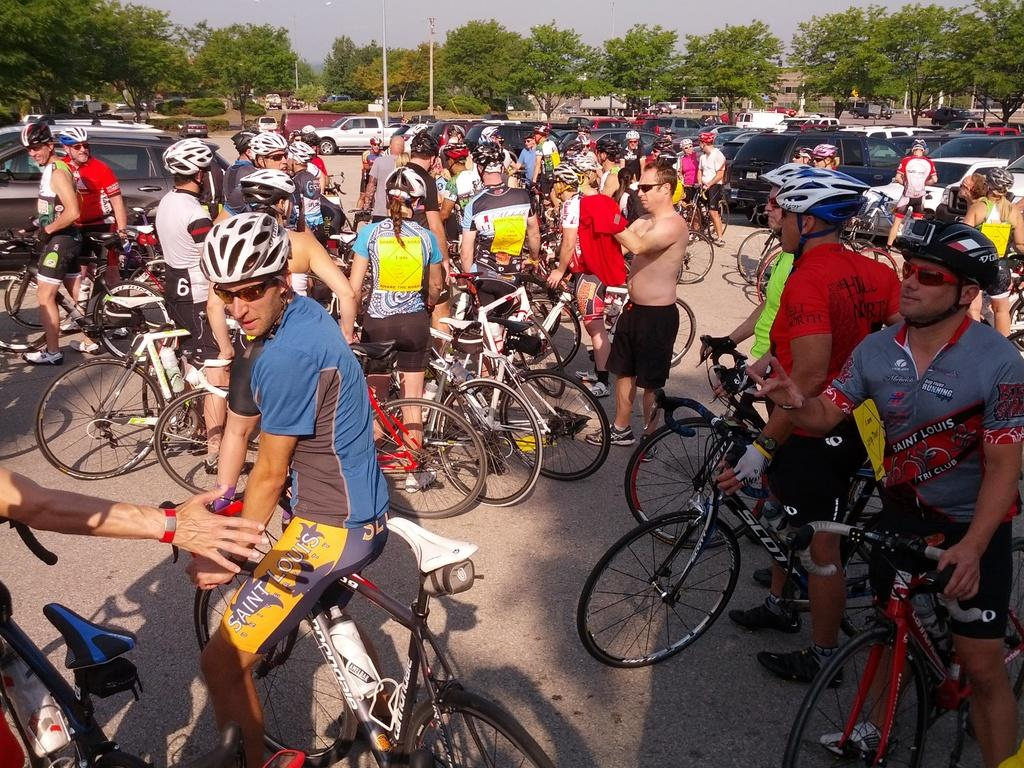What activity are the people in the image engaged in? The people in the image are cycle racers. What are the cycle racers doing in the middle of the image? The cycle racers are with their cycles in the middle of the image. What else can be seen in the image besides the cycle racers and their cycles? There are cars on either side of the cycle racers. What can be seen in the background of the image? There are trees in the background of the image. What is visible at the top of the image? The sky is visible at the top of the image. How do the cycle racers measure their interest in the image? The image does not show any indication of the cycle racers measuring their interest; it only depicts them with their cycles and cars on either side. 